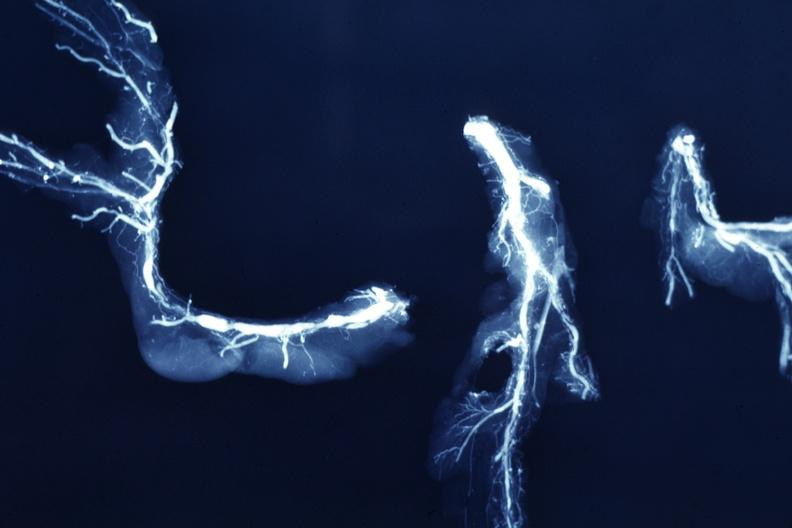what is present?
Answer the question using a single word or phrase. Coronary artery 